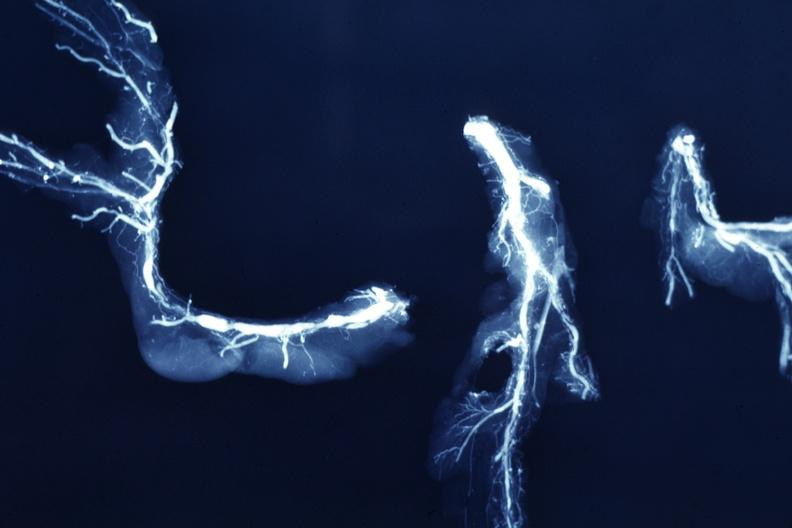what is present?
Answer the question using a single word or phrase. Coronary artery 